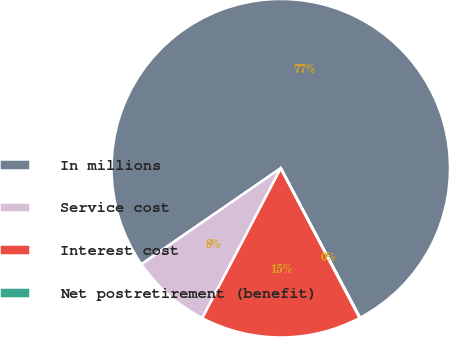Convert chart to OTSL. <chart><loc_0><loc_0><loc_500><loc_500><pie_chart><fcel>In millions<fcel>Service cost<fcel>Interest cost<fcel>Net postretirement (benefit)<nl><fcel>76.84%<fcel>7.72%<fcel>15.4%<fcel>0.04%<nl></chart> 